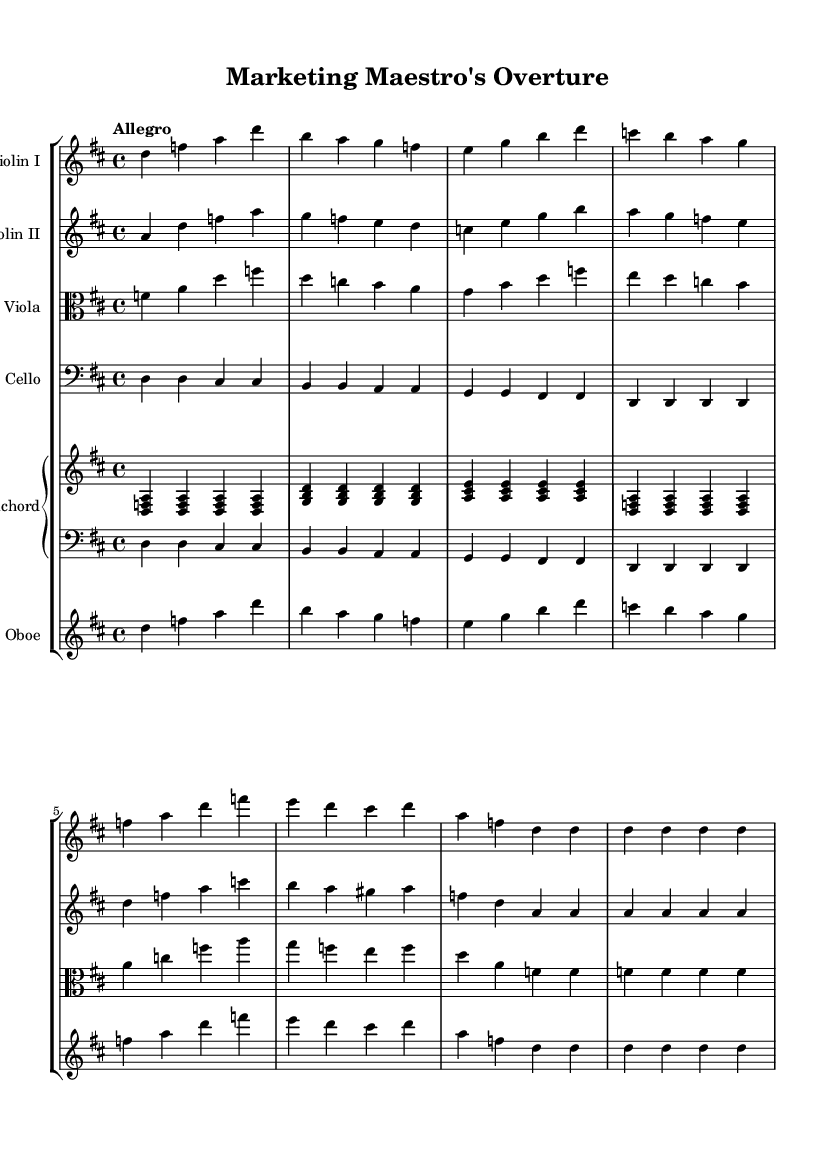What is the key signature of this music? The key signature is indicated at the beginning of the staff and shows two sharps (F# and C#), which corresponds to D major.
Answer: D major What is the time signature of this music? The time signature is shown at the beginning of the sheet music, represented by the fraction 4/4, indicating four beats per measure.
Answer: 4/4 What is the tempo marking for this piece? The tempo marking "Allegro" is provided at the top of the sheet music, indicating a fast and lively pace.
Answer: Allegro How many instruments are featured in this piece? By counting the labeled staves in the score, there are five distinct instruments: Violin I, Violin II, Viola, Cello, and Oboe, along with a Harpsichord part.
Answer: Five instruments Which instruments are playing in unison at the beginning of the music? The Violin I and Oboe sections play the same melody initially, which can be identified by their matching notes in the first measure.
Answer: Violin I and Oboe What is the role of the harpsichord in this piece? The harpsichord, indicated by its separate staff, provides harmonic support and rhythm, characteristic of Baroque orchestration, as seen in its repeating chordal patterns.
Answer: Harmonic support What type of articulation is commonly used in Baroque music as seen in this score? The dotted rhythms and accentuated notes in the Violin and Oboe parts suggest the use of terraced dynamics and articulations like staccato and legato phrasing typical of the Baroque style.
Answer: Terraced dynamics 